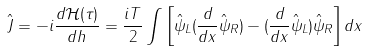Convert formula to latex. <formula><loc_0><loc_0><loc_500><loc_500>\hat { J } = - i \frac { d \mathcal { H } ( \tau ) } { d h } = \frac { i T } { 2 } \int \left [ \hat { \psi } _ { L } ( \frac { d } { d x } \hat { \psi } _ { R } ) - ( \frac { d } { d x } \hat { \psi } _ { L } ) \hat { \psi } _ { R } \right ] d x</formula> 